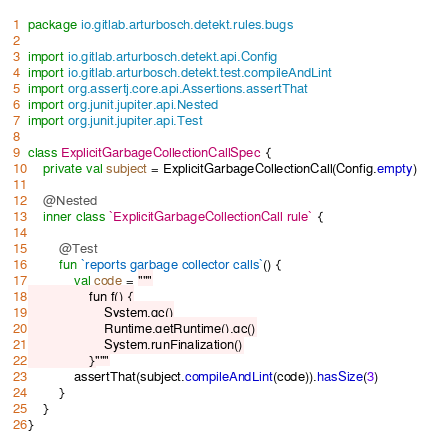Convert code to text. <code><loc_0><loc_0><loc_500><loc_500><_Kotlin_>package io.gitlab.arturbosch.detekt.rules.bugs

import io.gitlab.arturbosch.detekt.api.Config
import io.gitlab.arturbosch.detekt.test.compileAndLint
import org.assertj.core.api.Assertions.assertThat
import org.junit.jupiter.api.Nested
import org.junit.jupiter.api.Test

class ExplicitGarbageCollectionCallSpec {
    private val subject = ExplicitGarbageCollectionCall(Config.empty)

    @Nested
    inner class `ExplicitGarbageCollectionCall rule` {

        @Test
        fun `reports garbage collector calls`() {
            val code = """
                fun f() {
                    System.gc()
                    Runtime.getRuntime().gc()
                    System.runFinalization()
                }"""
            assertThat(subject.compileAndLint(code)).hasSize(3)
        }
    }
}
</code> 